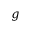Convert formula to latex. <formula><loc_0><loc_0><loc_500><loc_500>g</formula> 